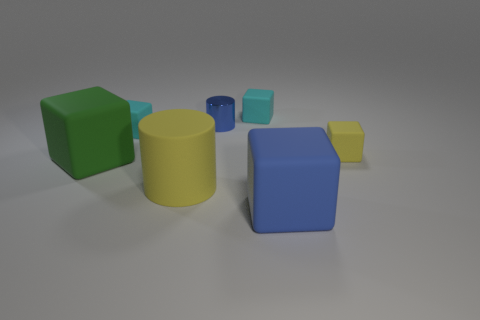How many other things are there of the same size as the yellow cylinder?
Ensure brevity in your answer.  2. There is a tiny rubber thing behind the blue object that is behind the yellow object behind the green block; what is its shape?
Offer a terse response. Cube. There is a blue object that is in front of the big yellow cylinder; is it the same shape as the small thing on the left side of the blue metallic object?
Your response must be concise. Yes. What number of other things are there of the same material as the big blue block
Offer a very short reply. 5. There is a tiny yellow thing that is made of the same material as the yellow cylinder; what shape is it?
Provide a succinct answer. Cube. Does the yellow rubber cube have the same size as the yellow matte cylinder?
Offer a very short reply. No. There is a cube in front of the cylinder in front of the tiny blue metal cylinder; what is its size?
Give a very brief answer. Large. There is a object that is the same color as the large cylinder; what shape is it?
Give a very brief answer. Cube. What number of cylinders are either cyan rubber objects or big yellow rubber things?
Make the answer very short. 1. There is a blue cylinder; is it the same size as the cyan cube right of the big yellow matte object?
Keep it short and to the point. Yes. 